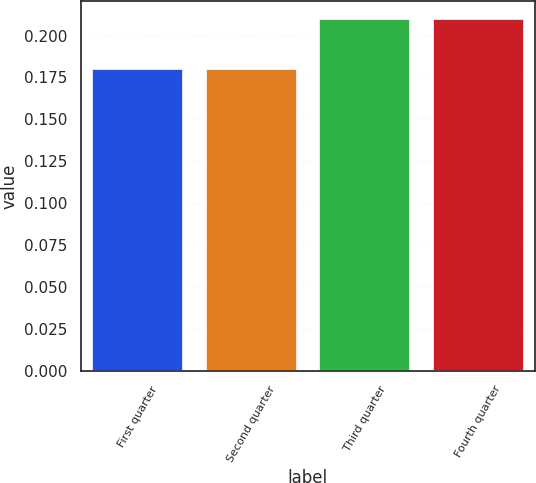Convert chart. <chart><loc_0><loc_0><loc_500><loc_500><bar_chart><fcel>First quarter<fcel>Second quarter<fcel>Third quarter<fcel>Fourth quarter<nl><fcel>0.18<fcel>0.18<fcel>0.21<fcel>0.21<nl></chart> 